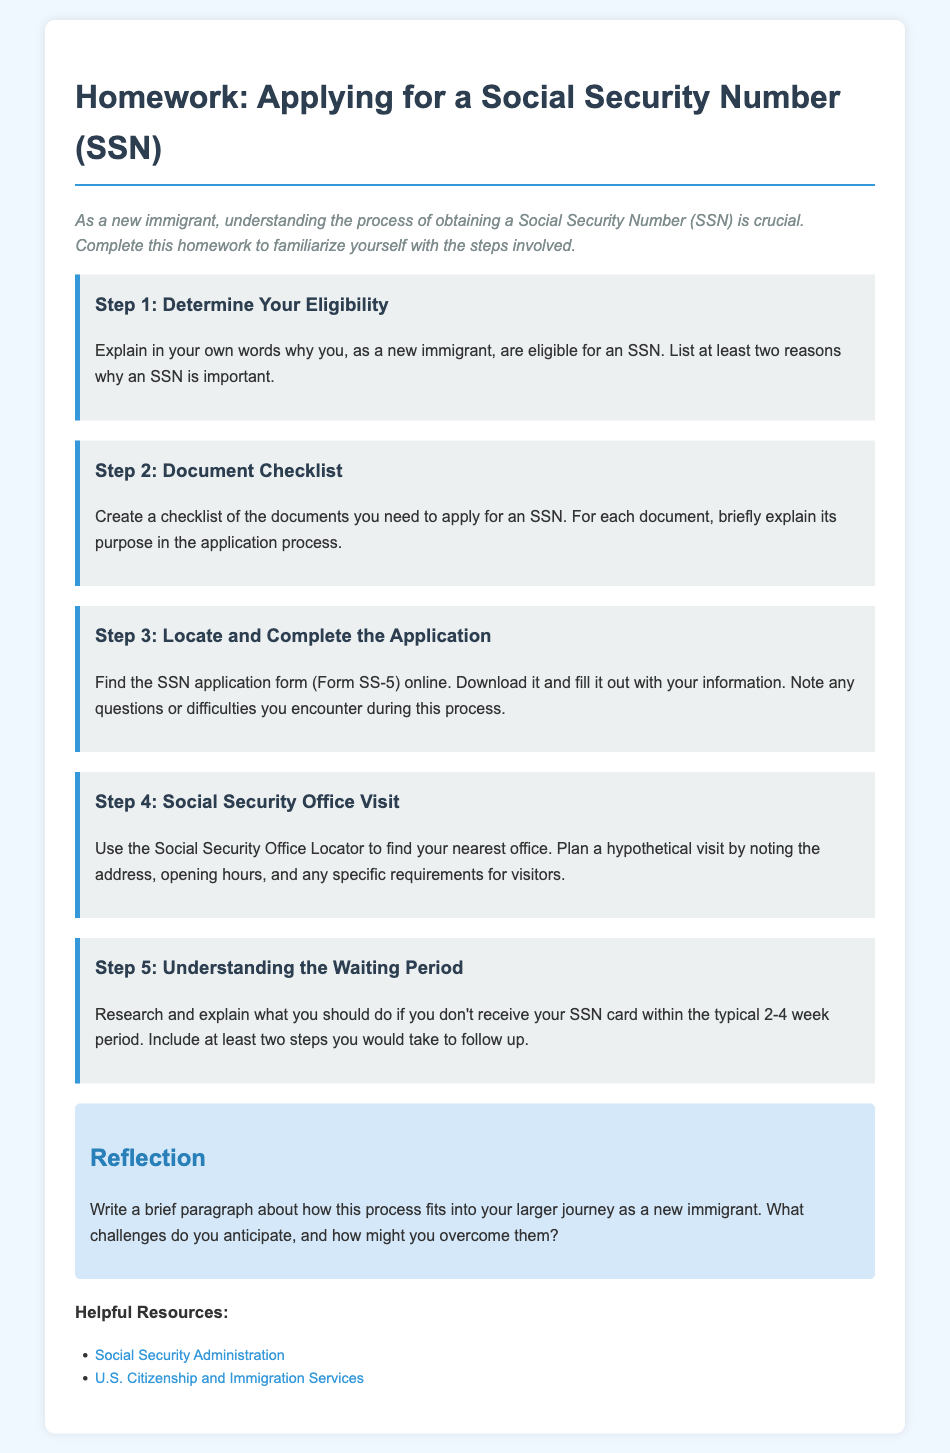what is the title of the document? The title of the document is found in the header of the page and provides the main topic of discussion.
Answer: Applying for a Social Security Number (SSN) how many steps are outlined in the guide? The number of steps is detailed within the content section of the document.
Answer: five name one source for helpful resources provided in the document. The sources section lists helpful resources for assistance related to the topic.
Answer: Social Security Administration what is the typical waiting period to receive an SSN card? The typical waiting period is mentioned clearly in the document as a timeframe for applicants.
Answer: 2-4 weeks in which step do you locate and complete the application? The sequence of the steps points out which step is focused on finding and filling out the application.
Answer: Step 3 what type of document do you need to download to apply for an SSN? The document type required for application is specified within the steps outlined.
Answer: Form SS-5 what should you do if you don’t receive your SSN card? The guide discusses actions to take if the SSN card is not received within the specified period.
Answer: Follow up what color is used for the header of the homework title? The specific color of the title is described within the styling of the document.
Answer: dark blue 